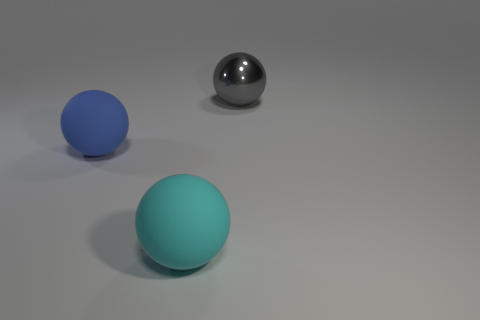There is another metal thing that is the same shape as the cyan object; what is its color?
Provide a succinct answer. Gray. How many other metal objects are the same color as the large shiny thing?
Ensure brevity in your answer.  0. Are there more big balls that are left of the large gray sphere than large gray metallic objects?
Make the answer very short. Yes. What is the color of the sphere that is in front of the matte sphere behind the large cyan thing?
Give a very brief answer. Cyan. What number of things are things that are in front of the gray ball or large rubber things to the left of the large cyan object?
Offer a terse response. 2. The big shiny sphere has what color?
Your answer should be very brief. Gray. How many gray objects are the same material as the cyan ball?
Ensure brevity in your answer.  0. Is the number of small red balls greater than the number of big gray balls?
Your answer should be compact. No. How many large blue matte spheres are in front of the big matte object that is left of the cyan ball?
Ensure brevity in your answer.  0. What number of things are big spheres behind the big cyan rubber sphere or rubber objects?
Your answer should be compact. 3. 